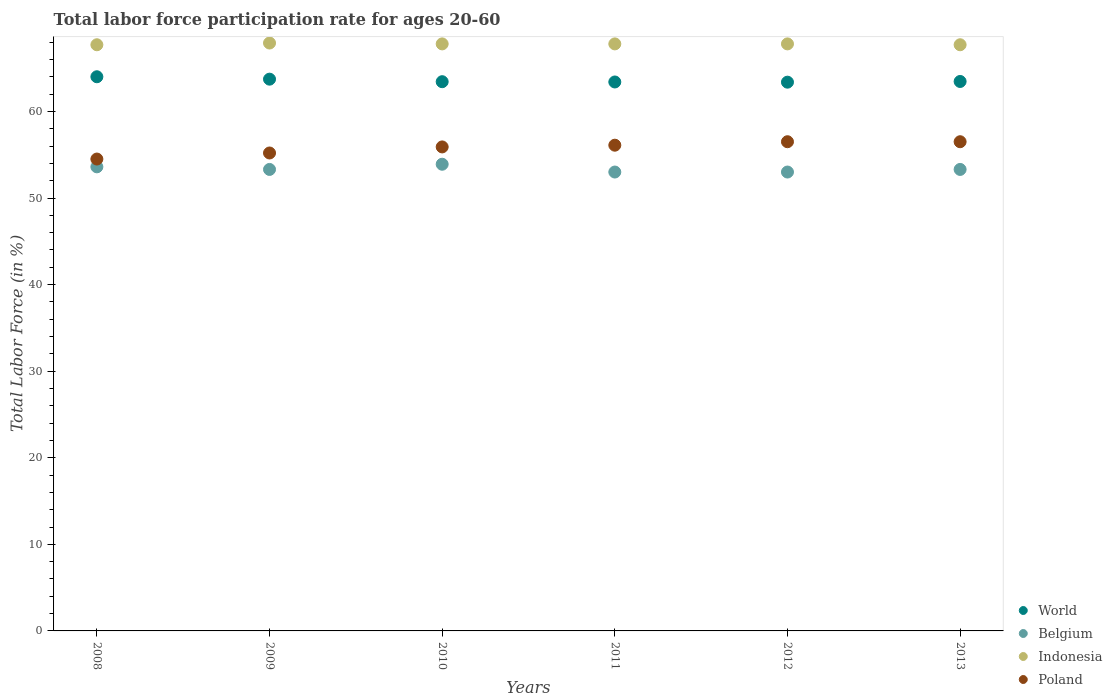What is the labor force participation rate in Belgium in 2012?
Your answer should be compact. 53. Across all years, what is the maximum labor force participation rate in Belgium?
Provide a short and direct response. 53.9. Across all years, what is the minimum labor force participation rate in World?
Provide a short and direct response. 63.38. In which year was the labor force participation rate in World minimum?
Provide a succinct answer. 2012. What is the total labor force participation rate in World in the graph?
Provide a short and direct response. 381.4. What is the difference between the labor force participation rate in World in 2008 and that in 2010?
Give a very brief answer. 0.57. What is the difference between the labor force participation rate in World in 2010 and the labor force participation rate in Belgium in 2008?
Provide a short and direct response. 9.83. What is the average labor force participation rate in Indonesia per year?
Make the answer very short. 67.78. In the year 2013, what is the difference between the labor force participation rate in Belgium and labor force participation rate in Poland?
Your answer should be compact. -3.2. What is the ratio of the labor force participation rate in Indonesia in 2011 to that in 2013?
Your answer should be compact. 1. Is the difference between the labor force participation rate in Belgium in 2012 and 2013 greater than the difference between the labor force participation rate in Poland in 2012 and 2013?
Ensure brevity in your answer.  No. What is the difference between the highest and the second highest labor force participation rate in Belgium?
Your answer should be very brief. 0.3. What is the difference between the highest and the lowest labor force participation rate in Belgium?
Provide a succinct answer. 0.9. In how many years, is the labor force participation rate in World greater than the average labor force participation rate in World taken over all years?
Offer a terse response. 2. Is it the case that in every year, the sum of the labor force participation rate in Indonesia and labor force participation rate in Poland  is greater than the labor force participation rate in World?
Offer a very short reply. Yes. Is the labor force participation rate in World strictly greater than the labor force participation rate in Belgium over the years?
Provide a short and direct response. Yes. Does the graph contain any zero values?
Give a very brief answer. No. Where does the legend appear in the graph?
Give a very brief answer. Bottom right. What is the title of the graph?
Keep it short and to the point. Total labor force participation rate for ages 20-60. Does "Fragile and conflict affected situations" appear as one of the legend labels in the graph?
Provide a short and direct response. No. What is the label or title of the Y-axis?
Provide a succinct answer. Total Labor Force (in %). What is the Total Labor Force (in %) of World in 2008?
Keep it short and to the point. 64. What is the Total Labor Force (in %) of Belgium in 2008?
Offer a terse response. 53.6. What is the Total Labor Force (in %) of Indonesia in 2008?
Offer a terse response. 67.7. What is the Total Labor Force (in %) of Poland in 2008?
Give a very brief answer. 54.5. What is the Total Labor Force (in %) of World in 2009?
Give a very brief answer. 63.73. What is the Total Labor Force (in %) in Belgium in 2009?
Keep it short and to the point. 53.3. What is the Total Labor Force (in %) of Indonesia in 2009?
Your answer should be compact. 67.9. What is the Total Labor Force (in %) of Poland in 2009?
Your answer should be compact. 55.2. What is the Total Labor Force (in %) of World in 2010?
Ensure brevity in your answer.  63.43. What is the Total Labor Force (in %) of Belgium in 2010?
Your answer should be very brief. 53.9. What is the Total Labor Force (in %) of Indonesia in 2010?
Give a very brief answer. 67.8. What is the Total Labor Force (in %) of Poland in 2010?
Keep it short and to the point. 55.9. What is the Total Labor Force (in %) in World in 2011?
Offer a terse response. 63.4. What is the Total Labor Force (in %) of Belgium in 2011?
Ensure brevity in your answer.  53. What is the Total Labor Force (in %) of Indonesia in 2011?
Your response must be concise. 67.8. What is the Total Labor Force (in %) in Poland in 2011?
Make the answer very short. 56.1. What is the Total Labor Force (in %) of World in 2012?
Make the answer very short. 63.38. What is the Total Labor Force (in %) in Indonesia in 2012?
Your answer should be very brief. 67.8. What is the Total Labor Force (in %) in Poland in 2012?
Your answer should be very brief. 56.5. What is the Total Labor Force (in %) of World in 2013?
Make the answer very short. 63.46. What is the Total Labor Force (in %) of Belgium in 2013?
Keep it short and to the point. 53.3. What is the Total Labor Force (in %) in Indonesia in 2013?
Offer a terse response. 67.7. What is the Total Labor Force (in %) of Poland in 2013?
Your response must be concise. 56.5. Across all years, what is the maximum Total Labor Force (in %) of World?
Give a very brief answer. 64. Across all years, what is the maximum Total Labor Force (in %) in Belgium?
Provide a succinct answer. 53.9. Across all years, what is the maximum Total Labor Force (in %) of Indonesia?
Provide a succinct answer. 67.9. Across all years, what is the maximum Total Labor Force (in %) in Poland?
Provide a succinct answer. 56.5. Across all years, what is the minimum Total Labor Force (in %) of World?
Provide a short and direct response. 63.38. Across all years, what is the minimum Total Labor Force (in %) of Belgium?
Keep it short and to the point. 53. Across all years, what is the minimum Total Labor Force (in %) of Indonesia?
Ensure brevity in your answer.  67.7. Across all years, what is the minimum Total Labor Force (in %) in Poland?
Your answer should be very brief. 54.5. What is the total Total Labor Force (in %) of World in the graph?
Make the answer very short. 381.4. What is the total Total Labor Force (in %) of Belgium in the graph?
Give a very brief answer. 320.1. What is the total Total Labor Force (in %) of Indonesia in the graph?
Your answer should be compact. 406.7. What is the total Total Labor Force (in %) in Poland in the graph?
Offer a very short reply. 334.7. What is the difference between the Total Labor Force (in %) in World in 2008 and that in 2009?
Make the answer very short. 0.28. What is the difference between the Total Labor Force (in %) of World in 2008 and that in 2010?
Provide a short and direct response. 0.57. What is the difference between the Total Labor Force (in %) in Belgium in 2008 and that in 2010?
Keep it short and to the point. -0.3. What is the difference between the Total Labor Force (in %) of Poland in 2008 and that in 2010?
Ensure brevity in your answer.  -1.4. What is the difference between the Total Labor Force (in %) of World in 2008 and that in 2011?
Ensure brevity in your answer.  0.6. What is the difference between the Total Labor Force (in %) in Belgium in 2008 and that in 2011?
Offer a very short reply. 0.6. What is the difference between the Total Labor Force (in %) of World in 2008 and that in 2012?
Your answer should be very brief. 0.63. What is the difference between the Total Labor Force (in %) in Indonesia in 2008 and that in 2012?
Give a very brief answer. -0.1. What is the difference between the Total Labor Force (in %) in World in 2008 and that in 2013?
Your answer should be compact. 0.55. What is the difference between the Total Labor Force (in %) of Poland in 2008 and that in 2013?
Provide a short and direct response. -2. What is the difference between the Total Labor Force (in %) of World in 2009 and that in 2010?
Give a very brief answer. 0.29. What is the difference between the Total Labor Force (in %) in Belgium in 2009 and that in 2010?
Provide a short and direct response. -0.6. What is the difference between the Total Labor Force (in %) of World in 2009 and that in 2011?
Provide a short and direct response. 0.33. What is the difference between the Total Labor Force (in %) of Poland in 2009 and that in 2011?
Ensure brevity in your answer.  -0.9. What is the difference between the Total Labor Force (in %) of World in 2009 and that in 2012?
Your answer should be compact. 0.35. What is the difference between the Total Labor Force (in %) of Belgium in 2009 and that in 2012?
Your answer should be compact. 0.3. What is the difference between the Total Labor Force (in %) of Poland in 2009 and that in 2012?
Your response must be concise. -1.3. What is the difference between the Total Labor Force (in %) of World in 2009 and that in 2013?
Ensure brevity in your answer.  0.27. What is the difference between the Total Labor Force (in %) of World in 2010 and that in 2011?
Offer a terse response. 0.03. What is the difference between the Total Labor Force (in %) of World in 2010 and that in 2012?
Provide a short and direct response. 0.05. What is the difference between the Total Labor Force (in %) of Poland in 2010 and that in 2012?
Give a very brief answer. -0.6. What is the difference between the Total Labor Force (in %) in World in 2010 and that in 2013?
Provide a succinct answer. -0.03. What is the difference between the Total Labor Force (in %) of Poland in 2010 and that in 2013?
Your answer should be compact. -0.6. What is the difference between the Total Labor Force (in %) of World in 2011 and that in 2012?
Give a very brief answer. 0.02. What is the difference between the Total Labor Force (in %) of Belgium in 2011 and that in 2012?
Provide a succinct answer. 0. What is the difference between the Total Labor Force (in %) of World in 2011 and that in 2013?
Keep it short and to the point. -0.06. What is the difference between the Total Labor Force (in %) in Belgium in 2011 and that in 2013?
Keep it short and to the point. -0.3. What is the difference between the Total Labor Force (in %) of World in 2012 and that in 2013?
Ensure brevity in your answer.  -0.08. What is the difference between the Total Labor Force (in %) in World in 2008 and the Total Labor Force (in %) in Belgium in 2009?
Give a very brief answer. 10.7. What is the difference between the Total Labor Force (in %) in World in 2008 and the Total Labor Force (in %) in Indonesia in 2009?
Make the answer very short. -3.9. What is the difference between the Total Labor Force (in %) of World in 2008 and the Total Labor Force (in %) of Poland in 2009?
Make the answer very short. 8.8. What is the difference between the Total Labor Force (in %) of Belgium in 2008 and the Total Labor Force (in %) of Indonesia in 2009?
Your response must be concise. -14.3. What is the difference between the Total Labor Force (in %) of World in 2008 and the Total Labor Force (in %) of Belgium in 2010?
Offer a terse response. 10.1. What is the difference between the Total Labor Force (in %) in World in 2008 and the Total Labor Force (in %) in Indonesia in 2010?
Provide a short and direct response. -3.8. What is the difference between the Total Labor Force (in %) in World in 2008 and the Total Labor Force (in %) in Poland in 2010?
Your response must be concise. 8.1. What is the difference between the Total Labor Force (in %) in Belgium in 2008 and the Total Labor Force (in %) in Indonesia in 2010?
Offer a very short reply. -14.2. What is the difference between the Total Labor Force (in %) in Belgium in 2008 and the Total Labor Force (in %) in Poland in 2010?
Give a very brief answer. -2.3. What is the difference between the Total Labor Force (in %) of World in 2008 and the Total Labor Force (in %) of Belgium in 2011?
Ensure brevity in your answer.  11. What is the difference between the Total Labor Force (in %) of World in 2008 and the Total Labor Force (in %) of Indonesia in 2011?
Keep it short and to the point. -3.8. What is the difference between the Total Labor Force (in %) of World in 2008 and the Total Labor Force (in %) of Poland in 2011?
Your answer should be very brief. 7.9. What is the difference between the Total Labor Force (in %) in Belgium in 2008 and the Total Labor Force (in %) in Poland in 2011?
Ensure brevity in your answer.  -2.5. What is the difference between the Total Labor Force (in %) of Indonesia in 2008 and the Total Labor Force (in %) of Poland in 2011?
Your answer should be very brief. 11.6. What is the difference between the Total Labor Force (in %) of World in 2008 and the Total Labor Force (in %) of Belgium in 2012?
Offer a very short reply. 11. What is the difference between the Total Labor Force (in %) in World in 2008 and the Total Labor Force (in %) in Indonesia in 2012?
Provide a short and direct response. -3.8. What is the difference between the Total Labor Force (in %) of World in 2008 and the Total Labor Force (in %) of Poland in 2012?
Offer a very short reply. 7.5. What is the difference between the Total Labor Force (in %) of Indonesia in 2008 and the Total Labor Force (in %) of Poland in 2012?
Ensure brevity in your answer.  11.2. What is the difference between the Total Labor Force (in %) in World in 2008 and the Total Labor Force (in %) in Belgium in 2013?
Offer a very short reply. 10.7. What is the difference between the Total Labor Force (in %) of World in 2008 and the Total Labor Force (in %) of Indonesia in 2013?
Make the answer very short. -3.7. What is the difference between the Total Labor Force (in %) of World in 2008 and the Total Labor Force (in %) of Poland in 2013?
Your answer should be very brief. 7.5. What is the difference between the Total Labor Force (in %) in Belgium in 2008 and the Total Labor Force (in %) in Indonesia in 2013?
Give a very brief answer. -14.1. What is the difference between the Total Labor Force (in %) in Indonesia in 2008 and the Total Labor Force (in %) in Poland in 2013?
Your answer should be very brief. 11.2. What is the difference between the Total Labor Force (in %) of World in 2009 and the Total Labor Force (in %) of Belgium in 2010?
Keep it short and to the point. 9.83. What is the difference between the Total Labor Force (in %) of World in 2009 and the Total Labor Force (in %) of Indonesia in 2010?
Offer a very short reply. -4.07. What is the difference between the Total Labor Force (in %) of World in 2009 and the Total Labor Force (in %) of Poland in 2010?
Offer a very short reply. 7.83. What is the difference between the Total Labor Force (in %) in Belgium in 2009 and the Total Labor Force (in %) in Poland in 2010?
Your response must be concise. -2.6. What is the difference between the Total Labor Force (in %) in Indonesia in 2009 and the Total Labor Force (in %) in Poland in 2010?
Your answer should be very brief. 12. What is the difference between the Total Labor Force (in %) in World in 2009 and the Total Labor Force (in %) in Belgium in 2011?
Ensure brevity in your answer.  10.73. What is the difference between the Total Labor Force (in %) in World in 2009 and the Total Labor Force (in %) in Indonesia in 2011?
Provide a succinct answer. -4.07. What is the difference between the Total Labor Force (in %) in World in 2009 and the Total Labor Force (in %) in Poland in 2011?
Ensure brevity in your answer.  7.63. What is the difference between the Total Labor Force (in %) of Indonesia in 2009 and the Total Labor Force (in %) of Poland in 2011?
Offer a terse response. 11.8. What is the difference between the Total Labor Force (in %) of World in 2009 and the Total Labor Force (in %) of Belgium in 2012?
Give a very brief answer. 10.73. What is the difference between the Total Labor Force (in %) of World in 2009 and the Total Labor Force (in %) of Indonesia in 2012?
Provide a succinct answer. -4.07. What is the difference between the Total Labor Force (in %) in World in 2009 and the Total Labor Force (in %) in Poland in 2012?
Your answer should be compact. 7.23. What is the difference between the Total Labor Force (in %) in Belgium in 2009 and the Total Labor Force (in %) in Poland in 2012?
Give a very brief answer. -3.2. What is the difference between the Total Labor Force (in %) of World in 2009 and the Total Labor Force (in %) of Belgium in 2013?
Your answer should be compact. 10.43. What is the difference between the Total Labor Force (in %) of World in 2009 and the Total Labor Force (in %) of Indonesia in 2013?
Your answer should be compact. -3.97. What is the difference between the Total Labor Force (in %) in World in 2009 and the Total Labor Force (in %) in Poland in 2013?
Provide a short and direct response. 7.23. What is the difference between the Total Labor Force (in %) of Belgium in 2009 and the Total Labor Force (in %) of Indonesia in 2013?
Offer a terse response. -14.4. What is the difference between the Total Labor Force (in %) of World in 2010 and the Total Labor Force (in %) of Belgium in 2011?
Ensure brevity in your answer.  10.43. What is the difference between the Total Labor Force (in %) of World in 2010 and the Total Labor Force (in %) of Indonesia in 2011?
Make the answer very short. -4.37. What is the difference between the Total Labor Force (in %) of World in 2010 and the Total Labor Force (in %) of Poland in 2011?
Give a very brief answer. 7.33. What is the difference between the Total Labor Force (in %) in World in 2010 and the Total Labor Force (in %) in Belgium in 2012?
Offer a terse response. 10.43. What is the difference between the Total Labor Force (in %) of World in 2010 and the Total Labor Force (in %) of Indonesia in 2012?
Your answer should be very brief. -4.37. What is the difference between the Total Labor Force (in %) in World in 2010 and the Total Labor Force (in %) in Poland in 2012?
Provide a short and direct response. 6.93. What is the difference between the Total Labor Force (in %) of Belgium in 2010 and the Total Labor Force (in %) of Poland in 2012?
Keep it short and to the point. -2.6. What is the difference between the Total Labor Force (in %) in World in 2010 and the Total Labor Force (in %) in Belgium in 2013?
Offer a terse response. 10.13. What is the difference between the Total Labor Force (in %) in World in 2010 and the Total Labor Force (in %) in Indonesia in 2013?
Make the answer very short. -4.27. What is the difference between the Total Labor Force (in %) in World in 2010 and the Total Labor Force (in %) in Poland in 2013?
Ensure brevity in your answer.  6.93. What is the difference between the Total Labor Force (in %) in Belgium in 2010 and the Total Labor Force (in %) in Poland in 2013?
Ensure brevity in your answer.  -2.6. What is the difference between the Total Labor Force (in %) of Indonesia in 2010 and the Total Labor Force (in %) of Poland in 2013?
Give a very brief answer. 11.3. What is the difference between the Total Labor Force (in %) in World in 2011 and the Total Labor Force (in %) in Belgium in 2012?
Ensure brevity in your answer.  10.4. What is the difference between the Total Labor Force (in %) in World in 2011 and the Total Labor Force (in %) in Indonesia in 2012?
Your answer should be very brief. -4.4. What is the difference between the Total Labor Force (in %) of World in 2011 and the Total Labor Force (in %) of Poland in 2012?
Your response must be concise. 6.9. What is the difference between the Total Labor Force (in %) in Belgium in 2011 and the Total Labor Force (in %) in Indonesia in 2012?
Make the answer very short. -14.8. What is the difference between the Total Labor Force (in %) of Belgium in 2011 and the Total Labor Force (in %) of Poland in 2012?
Ensure brevity in your answer.  -3.5. What is the difference between the Total Labor Force (in %) in World in 2011 and the Total Labor Force (in %) in Belgium in 2013?
Your answer should be very brief. 10.1. What is the difference between the Total Labor Force (in %) in World in 2011 and the Total Labor Force (in %) in Indonesia in 2013?
Ensure brevity in your answer.  -4.3. What is the difference between the Total Labor Force (in %) of World in 2011 and the Total Labor Force (in %) of Poland in 2013?
Provide a short and direct response. 6.9. What is the difference between the Total Labor Force (in %) in Belgium in 2011 and the Total Labor Force (in %) in Indonesia in 2013?
Offer a terse response. -14.7. What is the difference between the Total Labor Force (in %) of Belgium in 2011 and the Total Labor Force (in %) of Poland in 2013?
Ensure brevity in your answer.  -3.5. What is the difference between the Total Labor Force (in %) of World in 2012 and the Total Labor Force (in %) of Belgium in 2013?
Your answer should be very brief. 10.08. What is the difference between the Total Labor Force (in %) of World in 2012 and the Total Labor Force (in %) of Indonesia in 2013?
Keep it short and to the point. -4.32. What is the difference between the Total Labor Force (in %) of World in 2012 and the Total Labor Force (in %) of Poland in 2013?
Your answer should be very brief. 6.88. What is the difference between the Total Labor Force (in %) in Belgium in 2012 and the Total Labor Force (in %) in Indonesia in 2013?
Offer a terse response. -14.7. What is the difference between the Total Labor Force (in %) of Belgium in 2012 and the Total Labor Force (in %) of Poland in 2013?
Your response must be concise. -3.5. What is the average Total Labor Force (in %) of World per year?
Your answer should be compact. 63.57. What is the average Total Labor Force (in %) in Belgium per year?
Your response must be concise. 53.35. What is the average Total Labor Force (in %) in Indonesia per year?
Offer a very short reply. 67.78. What is the average Total Labor Force (in %) in Poland per year?
Offer a very short reply. 55.78. In the year 2008, what is the difference between the Total Labor Force (in %) of World and Total Labor Force (in %) of Belgium?
Your answer should be very brief. 10.4. In the year 2008, what is the difference between the Total Labor Force (in %) of World and Total Labor Force (in %) of Indonesia?
Your answer should be very brief. -3.7. In the year 2008, what is the difference between the Total Labor Force (in %) in World and Total Labor Force (in %) in Poland?
Provide a short and direct response. 9.5. In the year 2008, what is the difference between the Total Labor Force (in %) of Belgium and Total Labor Force (in %) of Indonesia?
Provide a succinct answer. -14.1. In the year 2008, what is the difference between the Total Labor Force (in %) of Indonesia and Total Labor Force (in %) of Poland?
Offer a very short reply. 13.2. In the year 2009, what is the difference between the Total Labor Force (in %) of World and Total Labor Force (in %) of Belgium?
Give a very brief answer. 10.43. In the year 2009, what is the difference between the Total Labor Force (in %) of World and Total Labor Force (in %) of Indonesia?
Make the answer very short. -4.17. In the year 2009, what is the difference between the Total Labor Force (in %) in World and Total Labor Force (in %) in Poland?
Make the answer very short. 8.53. In the year 2009, what is the difference between the Total Labor Force (in %) in Belgium and Total Labor Force (in %) in Indonesia?
Your response must be concise. -14.6. In the year 2009, what is the difference between the Total Labor Force (in %) in Indonesia and Total Labor Force (in %) in Poland?
Offer a very short reply. 12.7. In the year 2010, what is the difference between the Total Labor Force (in %) in World and Total Labor Force (in %) in Belgium?
Ensure brevity in your answer.  9.53. In the year 2010, what is the difference between the Total Labor Force (in %) in World and Total Labor Force (in %) in Indonesia?
Keep it short and to the point. -4.37. In the year 2010, what is the difference between the Total Labor Force (in %) of World and Total Labor Force (in %) of Poland?
Your answer should be compact. 7.53. In the year 2010, what is the difference between the Total Labor Force (in %) of Indonesia and Total Labor Force (in %) of Poland?
Make the answer very short. 11.9. In the year 2011, what is the difference between the Total Labor Force (in %) of World and Total Labor Force (in %) of Belgium?
Your response must be concise. 10.4. In the year 2011, what is the difference between the Total Labor Force (in %) of World and Total Labor Force (in %) of Indonesia?
Offer a very short reply. -4.4. In the year 2011, what is the difference between the Total Labor Force (in %) in World and Total Labor Force (in %) in Poland?
Offer a terse response. 7.3. In the year 2011, what is the difference between the Total Labor Force (in %) of Belgium and Total Labor Force (in %) of Indonesia?
Your answer should be very brief. -14.8. In the year 2011, what is the difference between the Total Labor Force (in %) in Belgium and Total Labor Force (in %) in Poland?
Keep it short and to the point. -3.1. In the year 2011, what is the difference between the Total Labor Force (in %) of Indonesia and Total Labor Force (in %) of Poland?
Your answer should be very brief. 11.7. In the year 2012, what is the difference between the Total Labor Force (in %) in World and Total Labor Force (in %) in Belgium?
Offer a terse response. 10.38. In the year 2012, what is the difference between the Total Labor Force (in %) in World and Total Labor Force (in %) in Indonesia?
Your answer should be compact. -4.42. In the year 2012, what is the difference between the Total Labor Force (in %) in World and Total Labor Force (in %) in Poland?
Your response must be concise. 6.88. In the year 2012, what is the difference between the Total Labor Force (in %) of Belgium and Total Labor Force (in %) of Indonesia?
Offer a very short reply. -14.8. In the year 2013, what is the difference between the Total Labor Force (in %) in World and Total Labor Force (in %) in Belgium?
Your answer should be very brief. 10.16. In the year 2013, what is the difference between the Total Labor Force (in %) in World and Total Labor Force (in %) in Indonesia?
Ensure brevity in your answer.  -4.24. In the year 2013, what is the difference between the Total Labor Force (in %) in World and Total Labor Force (in %) in Poland?
Ensure brevity in your answer.  6.96. In the year 2013, what is the difference between the Total Labor Force (in %) of Belgium and Total Labor Force (in %) of Indonesia?
Provide a short and direct response. -14.4. In the year 2013, what is the difference between the Total Labor Force (in %) of Belgium and Total Labor Force (in %) of Poland?
Provide a succinct answer. -3.2. In the year 2013, what is the difference between the Total Labor Force (in %) of Indonesia and Total Labor Force (in %) of Poland?
Ensure brevity in your answer.  11.2. What is the ratio of the Total Labor Force (in %) of World in 2008 to that in 2009?
Your answer should be very brief. 1. What is the ratio of the Total Labor Force (in %) of Belgium in 2008 to that in 2009?
Keep it short and to the point. 1.01. What is the ratio of the Total Labor Force (in %) in Poland in 2008 to that in 2009?
Your answer should be very brief. 0.99. What is the ratio of the Total Labor Force (in %) of World in 2008 to that in 2010?
Make the answer very short. 1.01. What is the ratio of the Total Labor Force (in %) of Belgium in 2008 to that in 2010?
Provide a short and direct response. 0.99. What is the ratio of the Total Labor Force (in %) in Indonesia in 2008 to that in 2010?
Your answer should be very brief. 1. What is the ratio of the Total Labor Force (in %) in Poland in 2008 to that in 2010?
Keep it short and to the point. 0.97. What is the ratio of the Total Labor Force (in %) of World in 2008 to that in 2011?
Your answer should be very brief. 1.01. What is the ratio of the Total Labor Force (in %) in Belgium in 2008 to that in 2011?
Provide a succinct answer. 1.01. What is the ratio of the Total Labor Force (in %) of Poland in 2008 to that in 2011?
Ensure brevity in your answer.  0.97. What is the ratio of the Total Labor Force (in %) in World in 2008 to that in 2012?
Your answer should be very brief. 1.01. What is the ratio of the Total Labor Force (in %) of Belgium in 2008 to that in 2012?
Provide a succinct answer. 1.01. What is the ratio of the Total Labor Force (in %) in Indonesia in 2008 to that in 2012?
Provide a succinct answer. 1. What is the ratio of the Total Labor Force (in %) of Poland in 2008 to that in 2012?
Offer a very short reply. 0.96. What is the ratio of the Total Labor Force (in %) of World in 2008 to that in 2013?
Ensure brevity in your answer.  1.01. What is the ratio of the Total Labor Force (in %) of Belgium in 2008 to that in 2013?
Ensure brevity in your answer.  1.01. What is the ratio of the Total Labor Force (in %) in Indonesia in 2008 to that in 2013?
Your answer should be very brief. 1. What is the ratio of the Total Labor Force (in %) of Poland in 2008 to that in 2013?
Your answer should be very brief. 0.96. What is the ratio of the Total Labor Force (in %) in Belgium in 2009 to that in 2010?
Offer a very short reply. 0.99. What is the ratio of the Total Labor Force (in %) in Poland in 2009 to that in 2010?
Provide a succinct answer. 0.99. What is the ratio of the Total Labor Force (in %) in Belgium in 2009 to that in 2011?
Ensure brevity in your answer.  1.01. What is the ratio of the Total Labor Force (in %) of Indonesia in 2009 to that in 2011?
Make the answer very short. 1. What is the ratio of the Total Labor Force (in %) in Poland in 2009 to that in 2011?
Make the answer very short. 0.98. What is the ratio of the Total Labor Force (in %) of Belgium in 2009 to that in 2012?
Your response must be concise. 1.01. What is the ratio of the Total Labor Force (in %) of Indonesia in 2009 to that in 2012?
Provide a succinct answer. 1. What is the ratio of the Total Labor Force (in %) of Poland in 2009 to that in 2012?
Offer a very short reply. 0.98. What is the ratio of the Total Labor Force (in %) in Belgium in 2009 to that in 2013?
Provide a short and direct response. 1. What is the ratio of the Total Labor Force (in %) of Poland in 2009 to that in 2013?
Your answer should be very brief. 0.98. What is the ratio of the Total Labor Force (in %) in World in 2010 to that in 2011?
Offer a terse response. 1. What is the ratio of the Total Labor Force (in %) in Indonesia in 2010 to that in 2011?
Offer a very short reply. 1. What is the ratio of the Total Labor Force (in %) in Indonesia in 2010 to that in 2012?
Provide a short and direct response. 1. What is the ratio of the Total Labor Force (in %) of Poland in 2010 to that in 2012?
Ensure brevity in your answer.  0.99. What is the ratio of the Total Labor Force (in %) of Belgium in 2010 to that in 2013?
Offer a terse response. 1.01. What is the ratio of the Total Labor Force (in %) in Indonesia in 2010 to that in 2013?
Ensure brevity in your answer.  1. What is the ratio of the Total Labor Force (in %) of Belgium in 2012 to that in 2013?
Keep it short and to the point. 0.99. What is the ratio of the Total Labor Force (in %) of Indonesia in 2012 to that in 2013?
Make the answer very short. 1. What is the ratio of the Total Labor Force (in %) of Poland in 2012 to that in 2013?
Keep it short and to the point. 1. What is the difference between the highest and the second highest Total Labor Force (in %) in World?
Keep it short and to the point. 0.28. What is the difference between the highest and the second highest Total Labor Force (in %) in Indonesia?
Provide a succinct answer. 0.1. What is the difference between the highest and the lowest Total Labor Force (in %) of World?
Keep it short and to the point. 0.63. What is the difference between the highest and the lowest Total Labor Force (in %) of Indonesia?
Keep it short and to the point. 0.2. What is the difference between the highest and the lowest Total Labor Force (in %) of Poland?
Offer a very short reply. 2. 